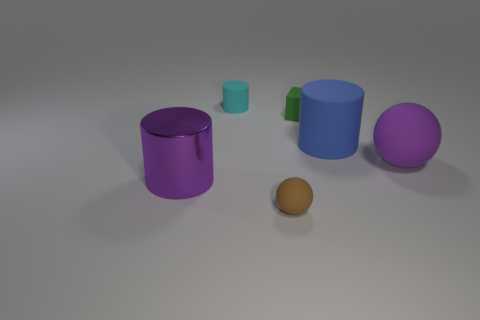How might the size of the objects relate to one another? The objects vary in size, creating a sense of perspective. The smallest green cylinder and the brown sphere are much smaller compared to the larger blue and purple cylinders and the violet sphere, suggesting a deliberate scaling to show depth or to invite contemplation on proportionality. 